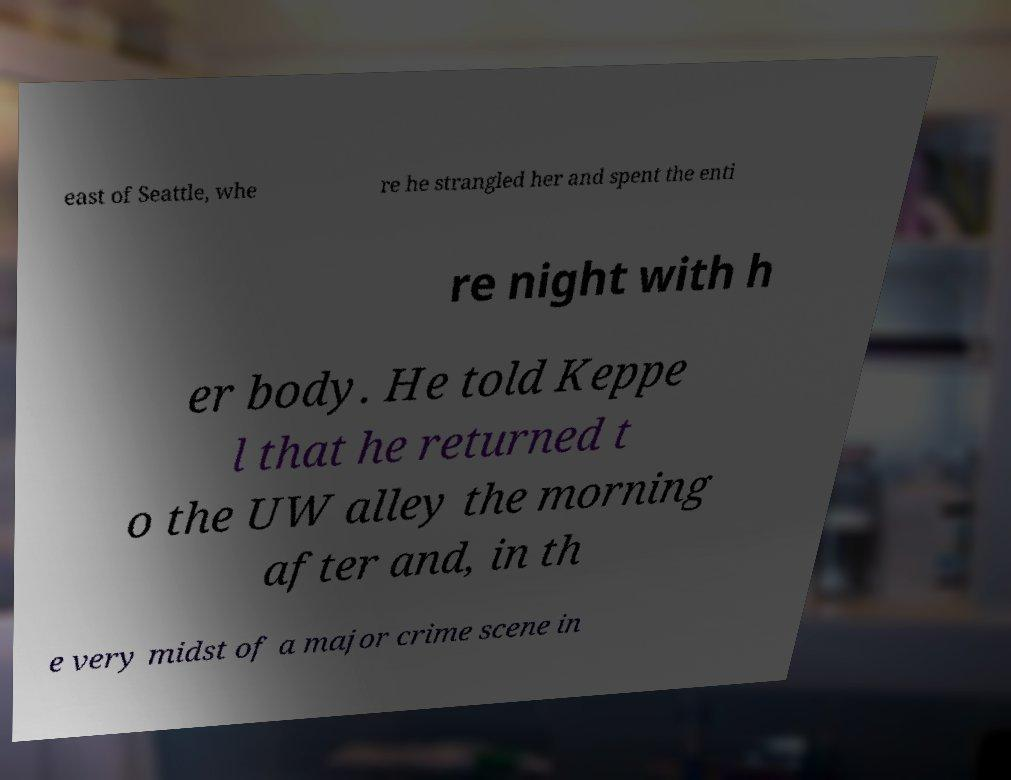What messages or text are displayed in this image? I need them in a readable, typed format. east of Seattle, whe re he strangled her and spent the enti re night with h er body. He told Keppe l that he returned t o the UW alley the morning after and, in th e very midst of a major crime scene in 